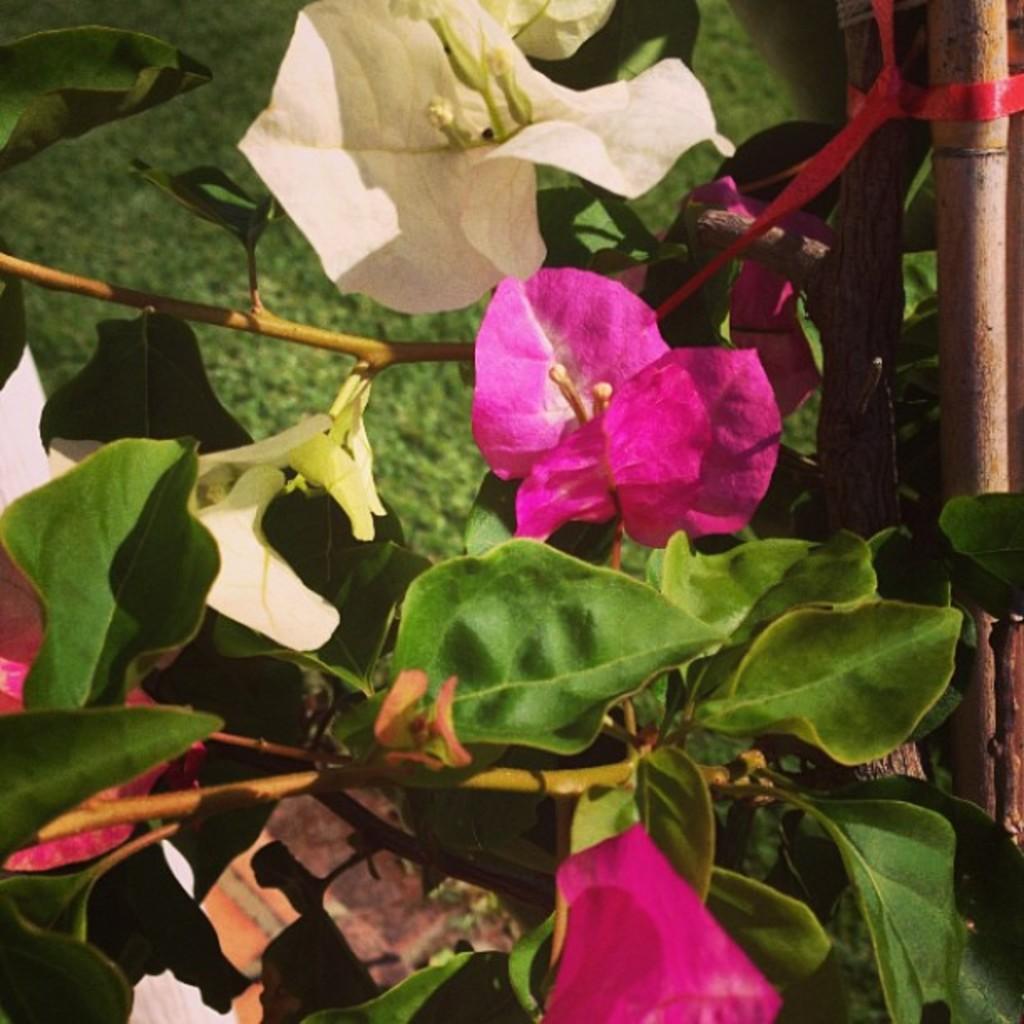How would you summarize this image in a sentence or two? In this image I can see a tree which is green and brown in color and I can see few flowers to the tree which are cream and pink in color and I can see a red colored rope tied to the tree. 